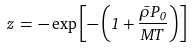Convert formula to latex. <formula><loc_0><loc_0><loc_500><loc_500>z \, = \, - \exp { \left [ - \left ( 1 + \frac { \bar { \rho } P _ { 0 } } { M T } \right ) \right ] }</formula> 